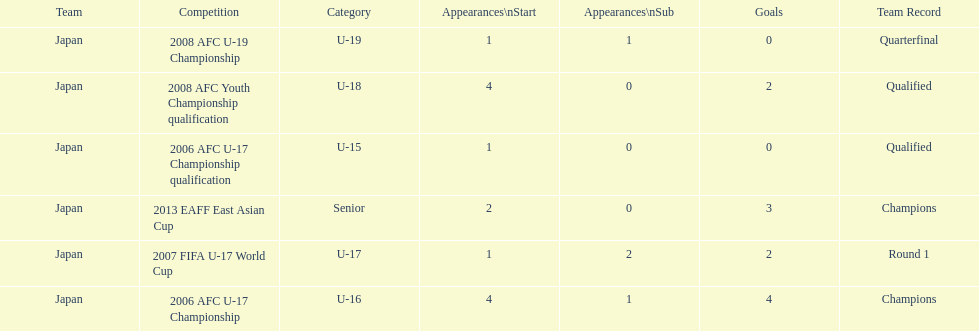Name the earliest competition to have a sub. 2006 AFC U-17 Championship. 